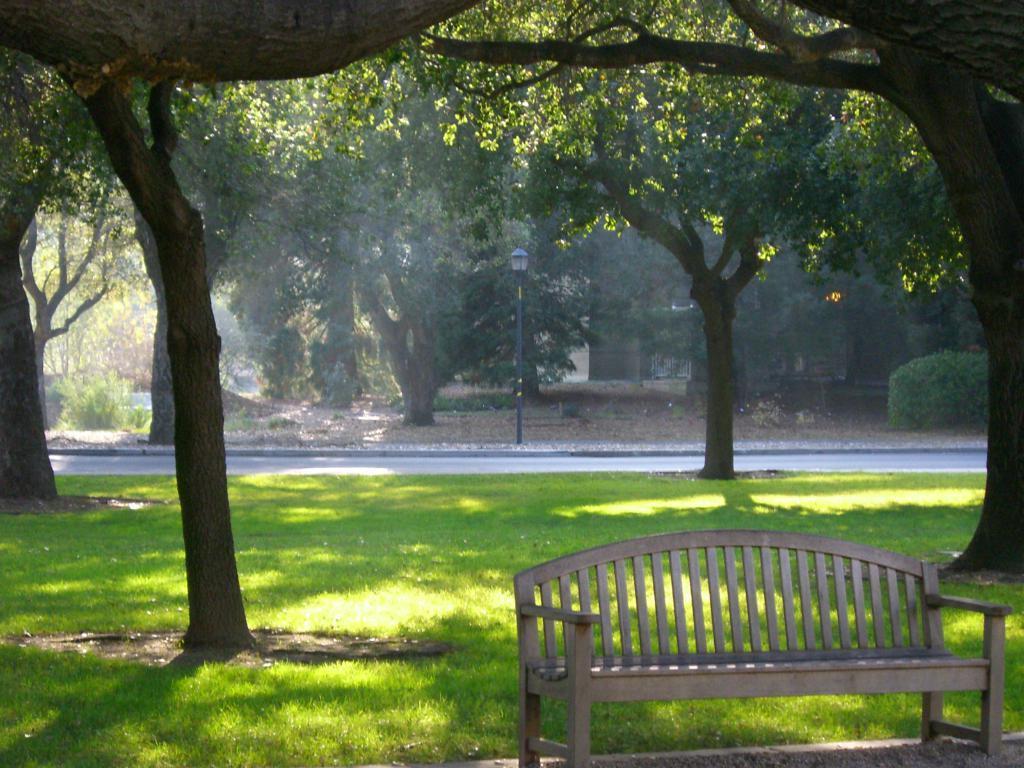Can you describe this image briefly? In this picture we can see a bench, grass, road, poland in the background we can see trees. 